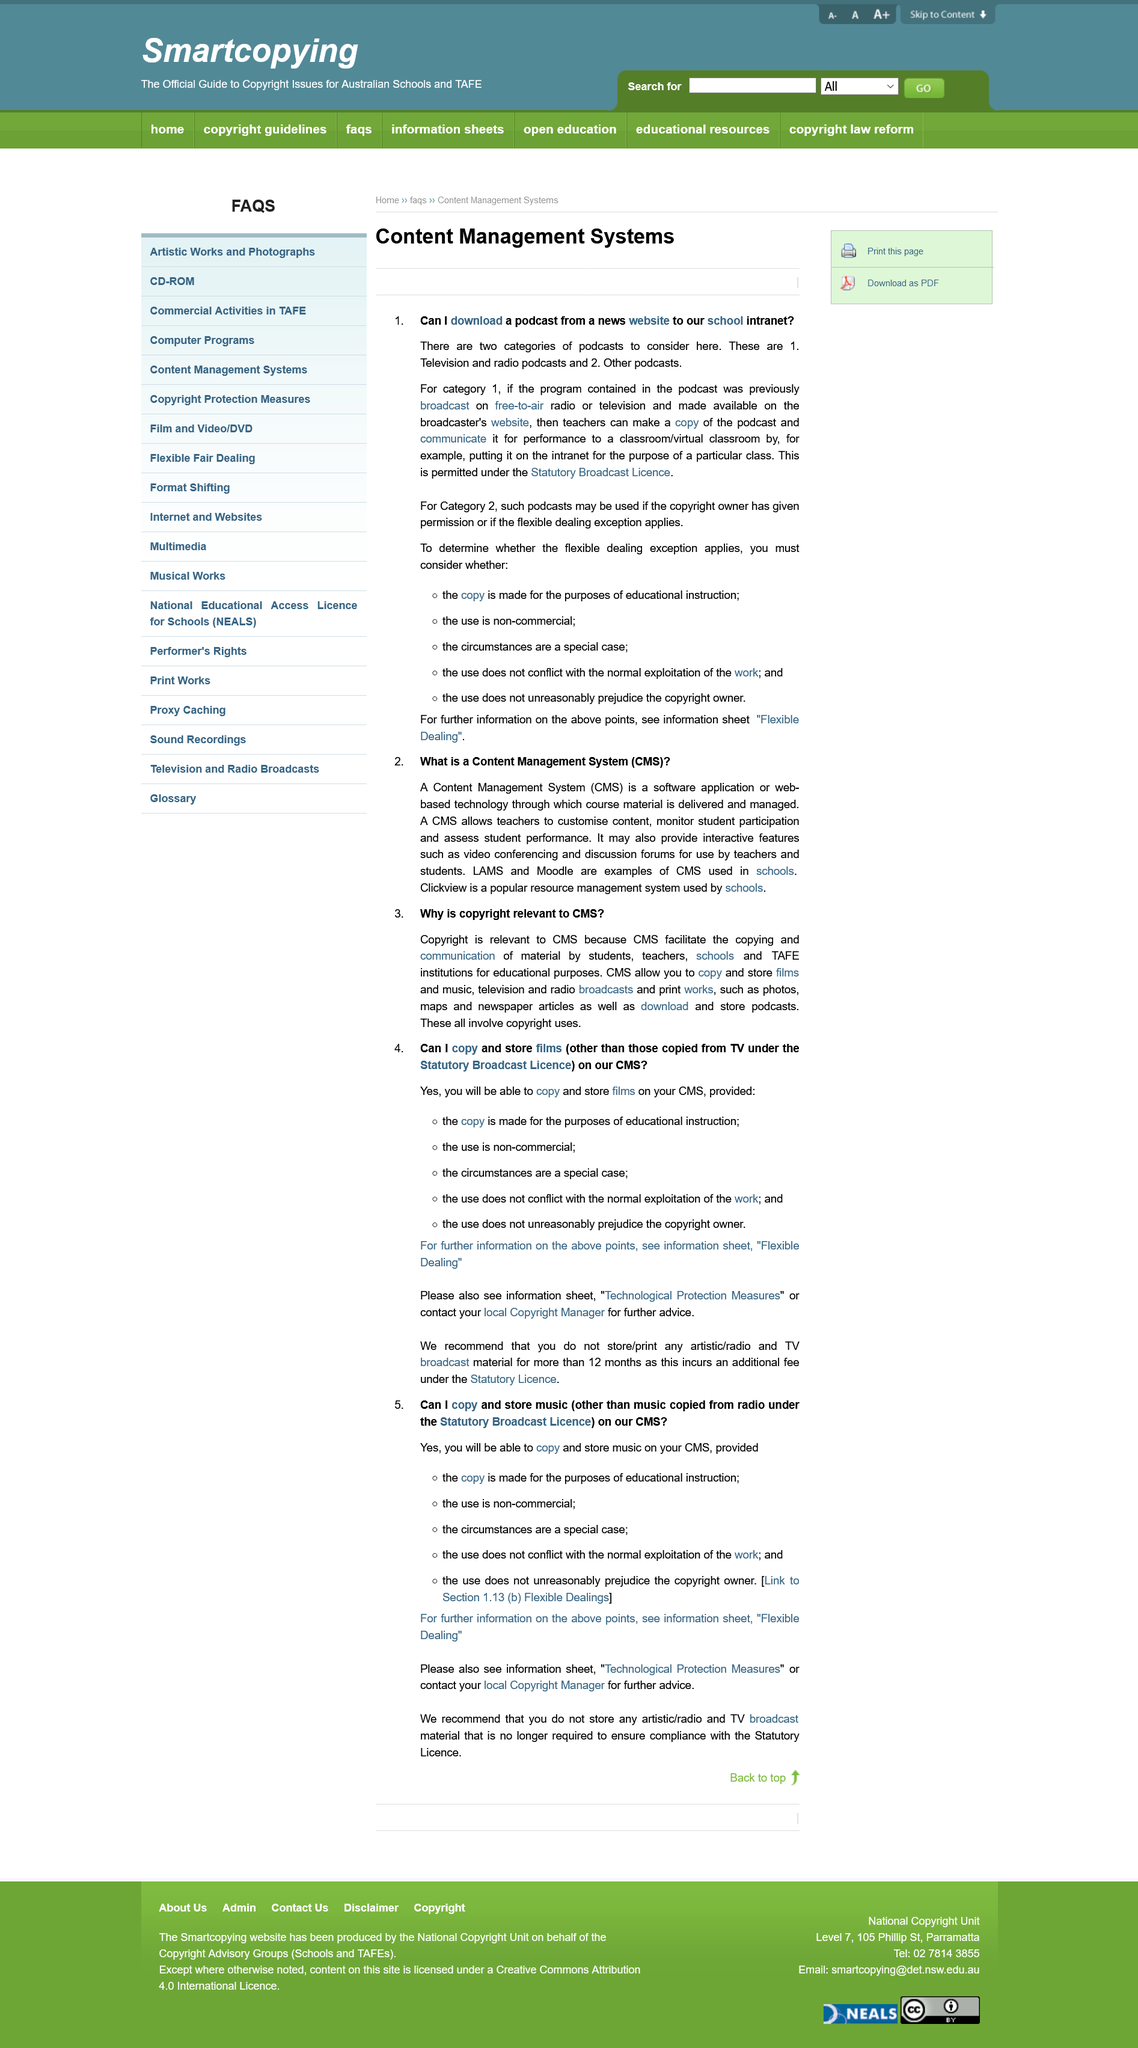List a handful of essential elements in this visual. It is not recommended to store broadcast material that is no longer required. It is acceptable to store radio or television broadcasts for a period of 12 months before additional fees are incurred. There are two types of podcasts mentioned in the passage. Under the circumstances of a special case for educational purposes and non-commercial use, it is appropriate to copy and store films on a CMS, as long as the use does not conflict with the normal exploitation of the work and does not unreasonably prejudice the copyright owner. The title of the current page is "Can I download a podcast from a news website to our school intranet?". 